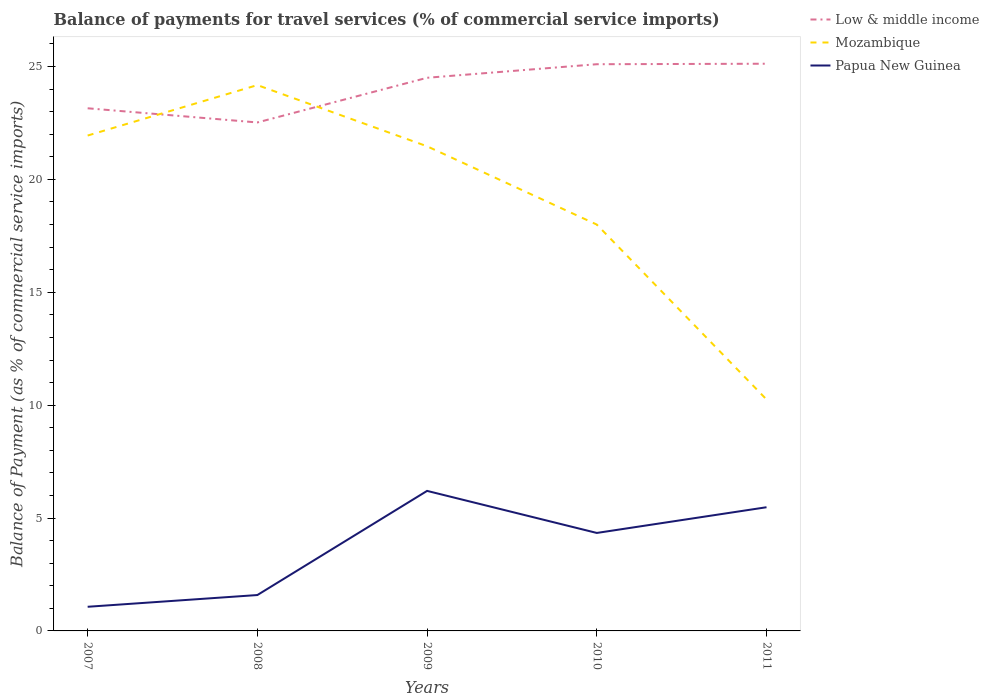How many different coloured lines are there?
Ensure brevity in your answer.  3. Does the line corresponding to Low & middle income intersect with the line corresponding to Papua New Guinea?
Keep it short and to the point. No. Across all years, what is the maximum balance of payments for travel services in Papua New Guinea?
Give a very brief answer. 1.07. In which year was the balance of payments for travel services in Mozambique maximum?
Provide a short and direct response. 2011. What is the total balance of payments for travel services in Mozambique in the graph?
Your answer should be very brief. 11.22. What is the difference between the highest and the second highest balance of payments for travel services in Low & middle income?
Provide a short and direct response. 2.6. How many lines are there?
Offer a terse response. 3. How many years are there in the graph?
Give a very brief answer. 5. What is the difference between two consecutive major ticks on the Y-axis?
Provide a short and direct response. 5. Does the graph contain any zero values?
Offer a terse response. No. Does the graph contain grids?
Your answer should be very brief. No. Where does the legend appear in the graph?
Provide a succinct answer. Top right. How many legend labels are there?
Ensure brevity in your answer.  3. What is the title of the graph?
Your response must be concise. Balance of payments for travel services (% of commercial service imports). What is the label or title of the Y-axis?
Offer a very short reply. Balance of Payment (as % of commercial service imports). What is the Balance of Payment (as % of commercial service imports) in Low & middle income in 2007?
Your answer should be very brief. 23.15. What is the Balance of Payment (as % of commercial service imports) in Mozambique in 2007?
Your response must be concise. 21.94. What is the Balance of Payment (as % of commercial service imports) in Papua New Guinea in 2007?
Your response must be concise. 1.07. What is the Balance of Payment (as % of commercial service imports) in Low & middle income in 2008?
Offer a very short reply. 22.52. What is the Balance of Payment (as % of commercial service imports) in Mozambique in 2008?
Give a very brief answer. 24.18. What is the Balance of Payment (as % of commercial service imports) of Papua New Guinea in 2008?
Keep it short and to the point. 1.59. What is the Balance of Payment (as % of commercial service imports) in Low & middle income in 2009?
Give a very brief answer. 24.5. What is the Balance of Payment (as % of commercial service imports) of Mozambique in 2009?
Your answer should be very brief. 21.47. What is the Balance of Payment (as % of commercial service imports) in Papua New Guinea in 2009?
Your answer should be compact. 6.2. What is the Balance of Payment (as % of commercial service imports) in Low & middle income in 2010?
Your response must be concise. 25.1. What is the Balance of Payment (as % of commercial service imports) of Mozambique in 2010?
Offer a terse response. 18. What is the Balance of Payment (as % of commercial service imports) of Papua New Guinea in 2010?
Your answer should be very brief. 4.34. What is the Balance of Payment (as % of commercial service imports) of Low & middle income in 2011?
Provide a short and direct response. 25.12. What is the Balance of Payment (as % of commercial service imports) in Mozambique in 2011?
Your response must be concise. 10.25. What is the Balance of Payment (as % of commercial service imports) of Papua New Guinea in 2011?
Make the answer very short. 5.48. Across all years, what is the maximum Balance of Payment (as % of commercial service imports) of Low & middle income?
Offer a terse response. 25.12. Across all years, what is the maximum Balance of Payment (as % of commercial service imports) of Mozambique?
Make the answer very short. 24.18. Across all years, what is the maximum Balance of Payment (as % of commercial service imports) of Papua New Guinea?
Make the answer very short. 6.2. Across all years, what is the minimum Balance of Payment (as % of commercial service imports) of Low & middle income?
Your answer should be compact. 22.52. Across all years, what is the minimum Balance of Payment (as % of commercial service imports) of Mozambique?
Your answer should be compact. 10.25. Across all years, what is the minimum Balance of Payment (as % of commercial service imports) in Papua New Guinea?
Offer a very short reply. 1.07. What is the total Balance of Payment (as % of commercial service imports) in Low & middle income in the graph?
Keep it short and to the point. 120.4. What is the total Balance of Payment (as % of commercial service imports) of Mozambique in the graph?
Your answer should be compact. 95.84. What is the total Balance of Payment (as % of commercial service imports) of Papua New Guinea in the graph?
Your response must be concise. 18.68. What is the difference between the Balance of Payment (as % of commercial service imports) in Low & middle income in 2007 and that in 2008?
Your response must be concise. 0.63. What is the difference between the Balance of Payment (as % of commercial service imports) of Mozambique in 2007 and that in 2008?
Offer a very short reply. -2.23. What is the difference between the Balance of Payment (as % of commercial service imports) in Papua New Guinea in 2007 and that in 2008?
Provide a succinct answer. -0.52. What is the difference between the Balance of Payment (as % of commercial service imports) of Low & middle income in 2007 and that in 2009?
Keep it short and to the point. -1.35. What is the difference between the Balance of Payment (as % of commercial service imports) of Mozambique in 2007 and that in 2009?
Offer a very short reply. 0.48. What is the difference between the Balance of Payment (as % of commercial service imports) of Papua New Guinea in 2007 and that in 2009?
Ensure brevity in your answer.  -5.13. What is the difference between the Balance of Payment (as % of commercial service imports) in Low & middle income in 2007 and that in 2010?
Ensure brevity in your answer.  -1.95. What is the difference between the Balance of Payment (as % of commercial service imports) of Mozambique in 2007 and that in 2010?
Keep it short and to the point. 3.94. What is the difference between the Balance of Payment (as % of commercial service imports) in Papua New Guinea in 2007 and that in 2010?
Offer a very short reply. -3.27. What is the difference between the Balance of Payment (as % of commercial service imports) of Low & middle income in 2007 and that in 2011?
Make the answer very short. -1.97. What is the difference between the Balance of Payment (as % of commercial service imports) of Mozambique in 2007 and that in 2011?
Provide a succinct answer. 11.69. What is the difference between the Balance of Payment (as % of commercial service imports) in Papua New Guinea in 2007 and that in 2011?
Keep it short and to the point. -4.41. What is the difference between the Balance of Payment (as % of commercial service imports) in Low & middle income in 2008 and that in 2009?
Provide a short and direct response. -1.98. What is the difference between the Balance of Payment (as % of commercial service imports) in Mozambique in 2008 and that in 2009?
Keep it short and to the point. 2.71. What is the difference between the Balance of Payment (as % of commercial service imports) in Papua New Guinea in 2008 and that in 2009?
Give a very brief answer. -4.61. What is the difference between the Balance of Payment (as % of commercial service imports) of Low & middle income in 2008 and that in 2010?
Your response must be concise. -2.58. What is the difference between the Balance of Payment (as % of commercial service imports) in Mozambique in 2008 and that in 2010?
Keep it short and to the point. 6.18. What is the difference between the Balance of Payment (as % of commercial service imports) of Papua New Guinea in 2008 and that in 2010?
Your answer should be very brief. -2.75. What is the difference between the Balance of Payment (as % of commercial service imports) of Low & middle income in 2008 and that in 2011?
Your response must be concise. -2.6. What is the difference between the Balance of Payment (as % of commercial service imports) in Mozambique in 2008 and that in 2011?
Offer a very short reply. 13.93. What is the difference between the Balance of Payment (as % of commercial service imports) in Papua New Guinea in 2008 and that in 2011?
Provide a succinct answer. -3.89. What is the difference between the Balance of Payment (as % of commercial service imports) of Low & middle income in 2009 and that in 2010?
Give a very brief answer. -0.6. What is the difference between the Balance of Payment (as % of commercial service imports) in Mozambique in 2009 and that in 2010?
Your answer should be very brief. 3.47. What is the difference between the Balance of Payment (as % of commercial service imports) in Papua New Guinea in 2009 and that in 2010?
Your response must be concise. 1.86. What is the difference between the Balance of Payment (as % of commercial service imports) in Low & middle income in 2009 and that in 2011?
Make the answer very short. -0.62. What is the difference between the Balance of Payment (as % of commercial service imports) in Mozambique in 2009 and that in 2011?
Offer a terse response. 11.22. What is the difference between the Balance of Payment (as % of commercial service imports) of Papua New Guinea in 2009 and that in 2011?
Your answer should be very brief. 0.72. What is the difference between the Balance of Payment (as % of commercial service imports) in Low & middle income in 2010 and that in 2011?
Make the answer very short. -0.02. What is the difference between the Balance of Payment (as % of commercial service imports) of Mozambique in 2010 and that in 2011?
Give a very brief answer. 7.75. What is the difference between the Balance of Payment (as % of commercial service imports) in Papua New Guinea in 2010 and that in 2011?
Provide a succinct answer. -1.14. What is the difference between the Balance of Payment (as % of commercial service imports) of Low & middle income in 2007 and the Balance of Payment (as % of commercial service imports) of Mozambique in 2008?
Your answer should be very brief. -1.03. What is the difference between the Balance of Payment (as % of commercial service imports) of Low & middle income in 2007 and the Balance of Payment (as % of commercial service imports) of Papua New Guinea in 2008?
Your answer should be compact. 21.56. What is the difference between the Balance of Payment (as % of commercial service imports) of Mozambique in 2007 and the Balance of Payment (as % of commercial service imports) of Papua New Guinea in 2008?
Keep it short and to the point. 20.35. What is the difference between the Balance of Payment (as % of commercial service imports) in Low & middle income in 2007 and the Balance of Payment (as % of commercial service imports) in Mozambique in 2009?
Offer a terse response. 1.68. What is the difference between the Balance of Payment (as % of commercial service imports) of Low & middle income in 2007 and the Balance of Payment (as % of commercial service imports) of Papua New Guinea in 2009?
Your answer should be compact. 16.95. What is the difference between the Balance of Payment (as % of commercial service imports) in Mozambique in 2007 and the Balance of Payment (as % of commercial service imports) in Papua New Guinea in 2009?
Your response must be concise. 15.74. What is the difference between the Balance of Payment (as % of commercial service imports) in Low & middle income in 2007 and the Balance of Payment (as % of commercial service imports) in Mozambique in 2010?
Your answer should be compact. 5.15. What is the difference between the Balance of Payment (as % of commercial service imports) of Low & middle income in 2007 and the Balance of Payment (as % of commercial service imports) of Papua New Guinea in 2010?
Provide a short and direct response. 18.81. What is the difference between the Balance of Payment (as % of commercial service imports) of Mozambique in 2007 and the Balance of Payment (as % of commercial service imports) of Papua New Guinea in 2010?
Your answer should be very brief. 17.6. What is the difference between the Balance of Payment (as % of commercial service imports) of Low & middle income in 2007 and the Balance of Payment (as % of commercial service imports) of Mozambique in 2011?
Make the answer very short. 12.9. What is the difference between the Balance of Payment (as % of commercial service imports) of Low & middle income in 2007 and the Balance of Payment (as % of commercial service imports) of Papua New Guinea in 2011?
Make the answer very short. 17.67. What is the difference between the Balance of Payment (as % of commercial service imports) in Mozambique in 2007 and the Balance of Payment (as % of commercial service imports) in Papua New Guinea in 2011?
Your answer should be very brief. 16.46. What is the difference between the Balance of Payment (as % of commercial service imports) in Low & middle income in 2008 and the Balance of Payment (as % of commercial service imports) in Mozambique in 2009?
Make the answer very short. 1.06. What is the difference between the Balance of Payment (as % of commercial service imports) in Low & middle income in 2008 and the Balance of Payment (as % of commercial service imports) in Papua New Guinea in 2009?
Ensure brevity in your answer.  16.32. What is the difference between the Balance of Payment (as % of commercial service imports) of Mozambique in 2008 and the Balance of Payment (as % of commercial service imports) of Papua New Guinea in 2009?
Offer a terse response. 17.98. What is the difference between the Balance of Payment (as % of commercial service imports) of Low & middle income in 2008 and the Balance of Payment (as % of commercial service imports) of Mozambique in 2010?
Make the answer very short. 4.52. What is the difference between the Balance of Payment (as % of commercial service imports) of Low & middle income in 2008 and the Balance of Payment (as % of commercial service imports) of Papua New Guinea in 2010?
Make the answer very short. 18.18. What is the difference between the Balance of Payment (as % of commercial service imports) of Mozambique in 2008 and the Balance of Payment (as % of commercial service imports) of Papua New Guinea in 2010?
Offer a terse response. 19.84. What is the difference between the Balance of Payment (as % of commercial service imports) in Low & middle income in 2008 and the Balance of Payment (as % of commercial service imports) in Mozambique in 2011?
Your answer should be compact. 12.27. What is the difference between the Balance of Payment (as % of commercial service imports) of Low & middle income in 2008 and the Balance of Payment (as % of commercial service imports) of Papua New Guinea in 2011?
Make the answer very short. 17.04. What is the difference between the Balance of Payment (as % of commercial service imports) of Mozambique in 2008 and the Balance of Payment (as % of commercial service imports) of Papua New Guinea in 2011?
Make the answer very short. 18.7. What is the difference between the Balance of Payment (as % of commercial service imports) of Low & middle income in 2009 and the Balance of Payment (as % of commercial service imports) of Mozambique in 2010?
Offer a terse response. 6.5. What is the difference between the Balance of Payment (as % of commercial service imports) in Low & middle income in 2009 and the Balance of Payment (as % of commercial service imports) in Papua New Guinea in 2010?
Provide a succinct answer. 20.16. What is the difference between the Balance of Payment (as % of commercial service imports) of Mozambique in 2009 and the Balance of Payment (as % of commercial service imports) of Papua New Guinea in 2010?
Your answer should be very brief. 17.13. What is the difference between the Balance of Payment (as % of commercial service imports) of Low & middle income in 2009 and the Balance of Payment (as % of commercial service imports) of Mozambique in 2011?
Offer a terse response. 14.25. What is the difference between the Balance of Payment (as % of commercial service imports) in Low & middle income in 2009 and the Balance of Payment (as % of commercial service imports) in Papua New Guinea in 2011?
Provide a short and direct response. 19.02. What is the difference between the Balance of Payment (as % of commercial service imports) in Mozambique in 2009 and the Balance of Payment (as % of commercial service imports) in Papua New Guinea in 2011?
Your answer should be very brief. 15.99. What is the difference between the Balance of Payment (as % of commercial service imports) of Low & middle income in 2010 and the Balance of Payment (as % of commercial service imports) of Mozambique in 2011?
Keep it short and to the point. 14.85. What is the difference between the Balance of Payment (as % of commercial service imports) of Low & middle income in 2010 and the Balance of Payment (as % of commercial service imports) of Papua New Guinea in 2011?
Provide a succinct answer. 19.62. What is the difference between the Balance of Payment (as % of commercial service imports) of Mozambique in 2010 and the Balance of Payment (as % of commercial service imports) of Papua New Guinea in 2011?
Keep it short and to the point. 12.52. What is the average Balance of Payment (as % of commercial service imports) in Low & middle income per year?
Offer a terse response. 24.08. What is the average Balance of Payment (as % of commercial service imports) in Mozambique per year?
Provide a short and direct response. 19.17. What is the average Balance of Payment (as % of commercial service imports) in Papua New Guinea per year?
Your answer should be very brief. 3.74. In the year 2007, what is the difference between the Balance of Payment (as % of commercial service imports) of Low & middle income and Balance of Payment (as % of commercial service imports) of Mozambique?
Provide a succinct answer. 1.21. In the year 2007, what is the difference between the Balance of Payment (as % of commercial service imports) in Low & middle income and Balance of Payment (as % of commercial service imports) in Papua New Guinea?
Ensure brevity in your answer.  22.08. In the year 2007, what is the difference between the Balance of Payment (as % of commercial service imports) of Mozambique and Balance of Payment (as % of commercial service imports) of Papua New Guinea?
Your response must be concise. 20.87. In the year 2008, what is the difference between the Balance of Payment (as % of commercial service imports) in Low & middle income and Balance of Payment (as % of commercial service imports) in Mozambique?
Your answer should be very brief. -1.65. In the year 2008, what is the difference between the Balance of Payment (as % of commercial service imports) of Low & middle income and Balance of Payment (as % of commercial service imports) of Papua New Guinea?
Your answer should be very brief. 20.93. In the year 2008, what is the difference between the Balance of Payment (as % of commercial service imports) of Mozambique and Balance of Payment (as % of commercial service imports) of Papua New Guinea?
Provide a short and direct response. 22.59. In the year 2009, what is the difference between the Balance of Payment (as % of commercial service imports) of Low & middle income and Balance of Payment (as % of commercial service imports) of Mozambique?
Your answer should be compact. 3.04. In the year 2009, what is the difference between the Balance of Payment (as % of commercial service imports) of Low & middle income and Balance of Payment (as % of commercial service imports) of Papua New Guinea?
Provide a short and direct response. 18.3. In the year 2009, what is the difference between the Balance of Payment (as % of commercial service imports) of Mozambique and Balance of Payment (as % of commercial service imports) of Papua New Guinea?
Provide a succinct answer. 15.26. In the year 2010, what is the difference between the Balance of Payment (as % of commercial service imports) in Low & middle income and Balance of Payment (as % of commercial service imports) in Mozambique?
Your answer should be compact. 7.1. In the year 2010, what is the difference between the Balance of Payment (as % of commercial service imports) in Low & middle income and Balance of Payment (as % of commercial service imports) in Papua New Guinea?
Your response must be concise. 20.76. In the year 2010, what is the difference between the Balance of Payment (as % of commercial service imports) of Mozambique and Balance of Payment (as % of commercial service imports) of Papua New Guinea?
Your response must be concise. 13.66. In the year 2011, what is the difference between the Balance of Payment (as % of commercial service imports) in Low & middle income and Balance of Payment (as % of commercial service imports) in Mozambique?
Offer a very short reply. 14.87. In the year 2011, what is the difference between the Balance of Payment (as % of commercial service imports) of Low & middle income and Balance of Payment (as % of commercial service imports) of Papua New Guinea?
Provide a succinct answer. 19.65. In the year 2011, what is the difference between the Balance of Payment (as % of commercial service imports) of Mozambique and Balance of Payment (as % of commercial service imports) of Papua New Guinea?
Give a very brief answer. 4.77. What is the ratio of the Balance of Payment (as % of commercial service imports) of Low & middle income in 2007 to that in 2008?
Provide a succinct answer. 1.03. What is the ratio of the Balance of Payment (as % of commercial service imports) in Mozambique in 2007 to that in 2008?
Your answer should be compact. 0.91. What is the ratio of the Balance of Payment (as % of commercial service imports) of Papua New Guinea in 2007 to that in 2008?
Make the answer very short. 0.67. What is the ratio of the Balance of Payment (as % of commercial service imports) of Low & middle income in 2007 to that in 2009?
Make the answer very short. 0.94. What is the ratio of the Balance of Payment (as % of commercial service imports) in Mozambique in 2007 to that in 2009?
Offer a terse response. 1.02. What is the ratio of the Balance of Payment (as % of commercial service imports) in Papua New Guinea in 2007 to that in 2009?
Your answer should be very brief. 0.17. What is the ratio of the Balance of Payment (as % of commercial service imports) of Low & middle income in 2007 to that in 2010?
Your answer should be very brief. 0.92. What is the ratio of the Balance of Payment (as % of commercial service imports) in Mozambique in 2007 to that in 2010?
Provide a succinct answer. 1.22. What is the ratio of the Balance of Payment (as % of commercial service imports) of Papua New Guinea in 2007 to that in 2010?
Provide a succinct answer. 0.25. What is the ratio of the Balance of Payment (as % of commercial service imports) of Low & middle income in 2007 to that in 2011?
Your answer should be compact. 0.92. What is the ratio of the Balance of Payment (as % of commercial service imports) in Mozambique in 2007 to that in 2011?
Give a very brief answer. 2.14. What is the ratio of the Balance of Payment (as % of commercial service imports) of Papua New Guinea in 2007 to that in 2011?
Offer a very short reply. 0.2. What is the ratio of the Balance of Payment (as % of commercial service imports) of Low & middle income in 2008 to that in 2009?
Offer a very short reply. 0.92. What is the ratio of the Balance of Payment (as % of commercial service imports) of Mozambique in 2008 to that in 2009?
Provide a short and direct response. 1.13. What is the ratio of the Balance of Payment (as % of commercial service imports) in Papua New Guinea in 2008 to that in 2009?
Provide a short and direct response. 0.26. What is the ratio of the Balance of Payment (as % of commercial service imports) of Low & middle income in 2008 to that in 2010?
Offer a terse response. 0.9. What is the ratio of the Balance of Payment (as % of commercial service imports) in Mozambique in 2008 to that in 2010?
Keep it short and to the point. 1.34. What is the ratio of the Balance of Payment (as % of commercial service imports) in Papua New Guinea in 2008 to that in 2010?
Make the answer very short. 0.37. What is the ratio of the Balance of Payment (as % of commercial service imports) in Low & middle income in 2008 to that in 2011?
Your response must be concise. 0.9. What is the ratio of the Balance of Payment (as % of commercial service imports) of Mozambique in 2008 to that in 2011?
Make the answer very short. 2.36. What is the ratio of the Balance of Payment (as % of commercial service imports) in Papua New Guinea in 2008 to that in 2011?
Offer a very short reply. 0.29. What is the ratio of the Balance of Payment (as % of commercial service imports) in Low & middle income in 2009 to that in 2010?
Your response must be concise. 0.98. What is the ratio of the Balance of Payment (as % of commercial service imports) of Mozambique in 2009 to that in 2010?
Keep it short and to the point. 1.19. What is the ratio of the Balance of Payment (as % of commercial service imports) of Papua New Guinea in 2009 to that in 2010?
Offer a terse response. 1.43. What is the ratio of the Balance of Payment (as % of commercial service imports) of Low & middle income in 2009 to that in 2011?
Give a very brief answer. 0.98. What is the ratio of the Balance of Payment (as % of commercial service imports) of Mozambique in 2009 to that in 2011?
Offer a terse response. 2.09. What is the ratio of the Balance of Payment (as % of commercial service imports) in Papua New Guinea in 2009 to that in 2011?
Offer a terse response. 1.13. What is the ratio of the Balance of Payment (as % of commercial service imports) in Low & middle income in 2010 to that in 2011?
Your answer should be compact. 1. What is the ratio of the Balance of Payment (as % of commercial service imports) of Mozambique in 2010 to that in 2011?
Ensure brevity in your answer.  1.76. What is the ratio of the Balance of Payment (as % of commercial service imports) of Papua New Guinea in 2010 to that in 2011?
Provide a short and direct response. 0.79. What is the difference between the highest and the second highest Balance of Payment (as % of commercial service imports) of Low & middle income?
Make the answer very short. 0.02. What is the difference between the highest and the second highest Balance of Payment (as % of commercial service imports) in Mozambique?
Give a very brief answer. 2.23. What is the difference between the highest and the second highest Balance of Payment (as % of commercial service imports) in Papua New Guinea?
Your response must be concise. 0.72. What is the difference between the highest and the lowest Balance of Payment (as % of commercial service imports) in Low & middle income?
Your answer should be very brief. 2.6. What is the difference between the highest and the lowest Balance of Payment (as % of commercial service imports) in Mozambique?
Make the answer very short. 13.93. What is the difference between the highest and the lowest Balance of Payment (as % of commercial service imports) of Papua New Guinea?
Ensure brevity in your answer.  5.13. 